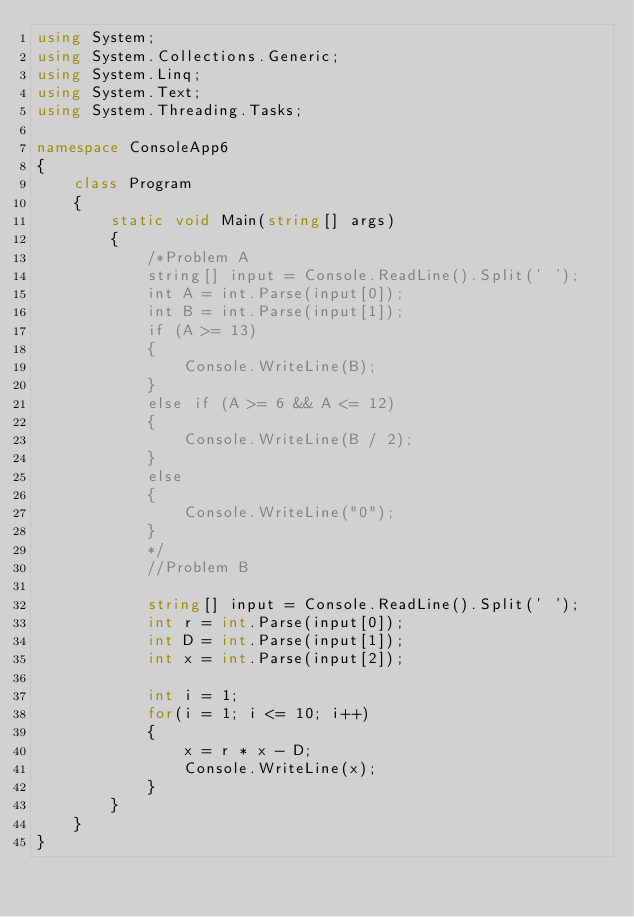Convert code to text. <code><loc_0><loc_0><loc_500><loc_500><_C#_>using System;
using System.Collections.Generic;
using System.Linq;
using System.Text;
using System.Threading.Tasks;

namespace ConsoleApp6
{
    class Program
    {
        static void Main(string[] args)
        {
            /*Problem A
            string[] input = Console.ReadLine().Split(' ');
            int A = int.Parse(input[0]);
            int B = int.Parse(input[1]);
            if (A >= 13)
            {
                Console.WriteLine(B);
            }
            else if (A >= 6 && A <= 12)
            {
                Console.WriteLine(B / 2);
            }
            else
            {
                Console.WriteLine("0");
            }
            */
            //Problem B

            string[] input = Console.ReadLine().Split(' ');
            int r = int.Parse(input[0]);
            int D = int.Parse(input[1]);
            int x = int.Parse(input[2]);

            int i = 1;
            for(i = 1; i <= 10; i++)
            {
                x = r * x - D;
                Console.WriteLine(x);
            }
        }
    }
}
</code> 